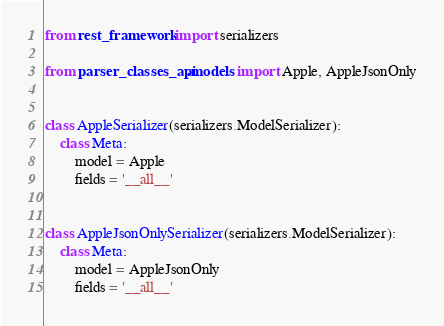Convert code to text. <code><loc_0><loc_0><loc_500><loc_500><_Python_>from rest_framework import serializers

from parser_classes_api.models import Apple, AppleJsonOnly


class AppleSerializer(serializers.ModelSerializer):
    class Meta:
        model = Apple
        fields = '__all__'


class AppleJsonOnlySerializer(serializers.ModelSerializer):
    class Meta:
        model = AppleJsonOnly
        fields = '__all__'
</code> 